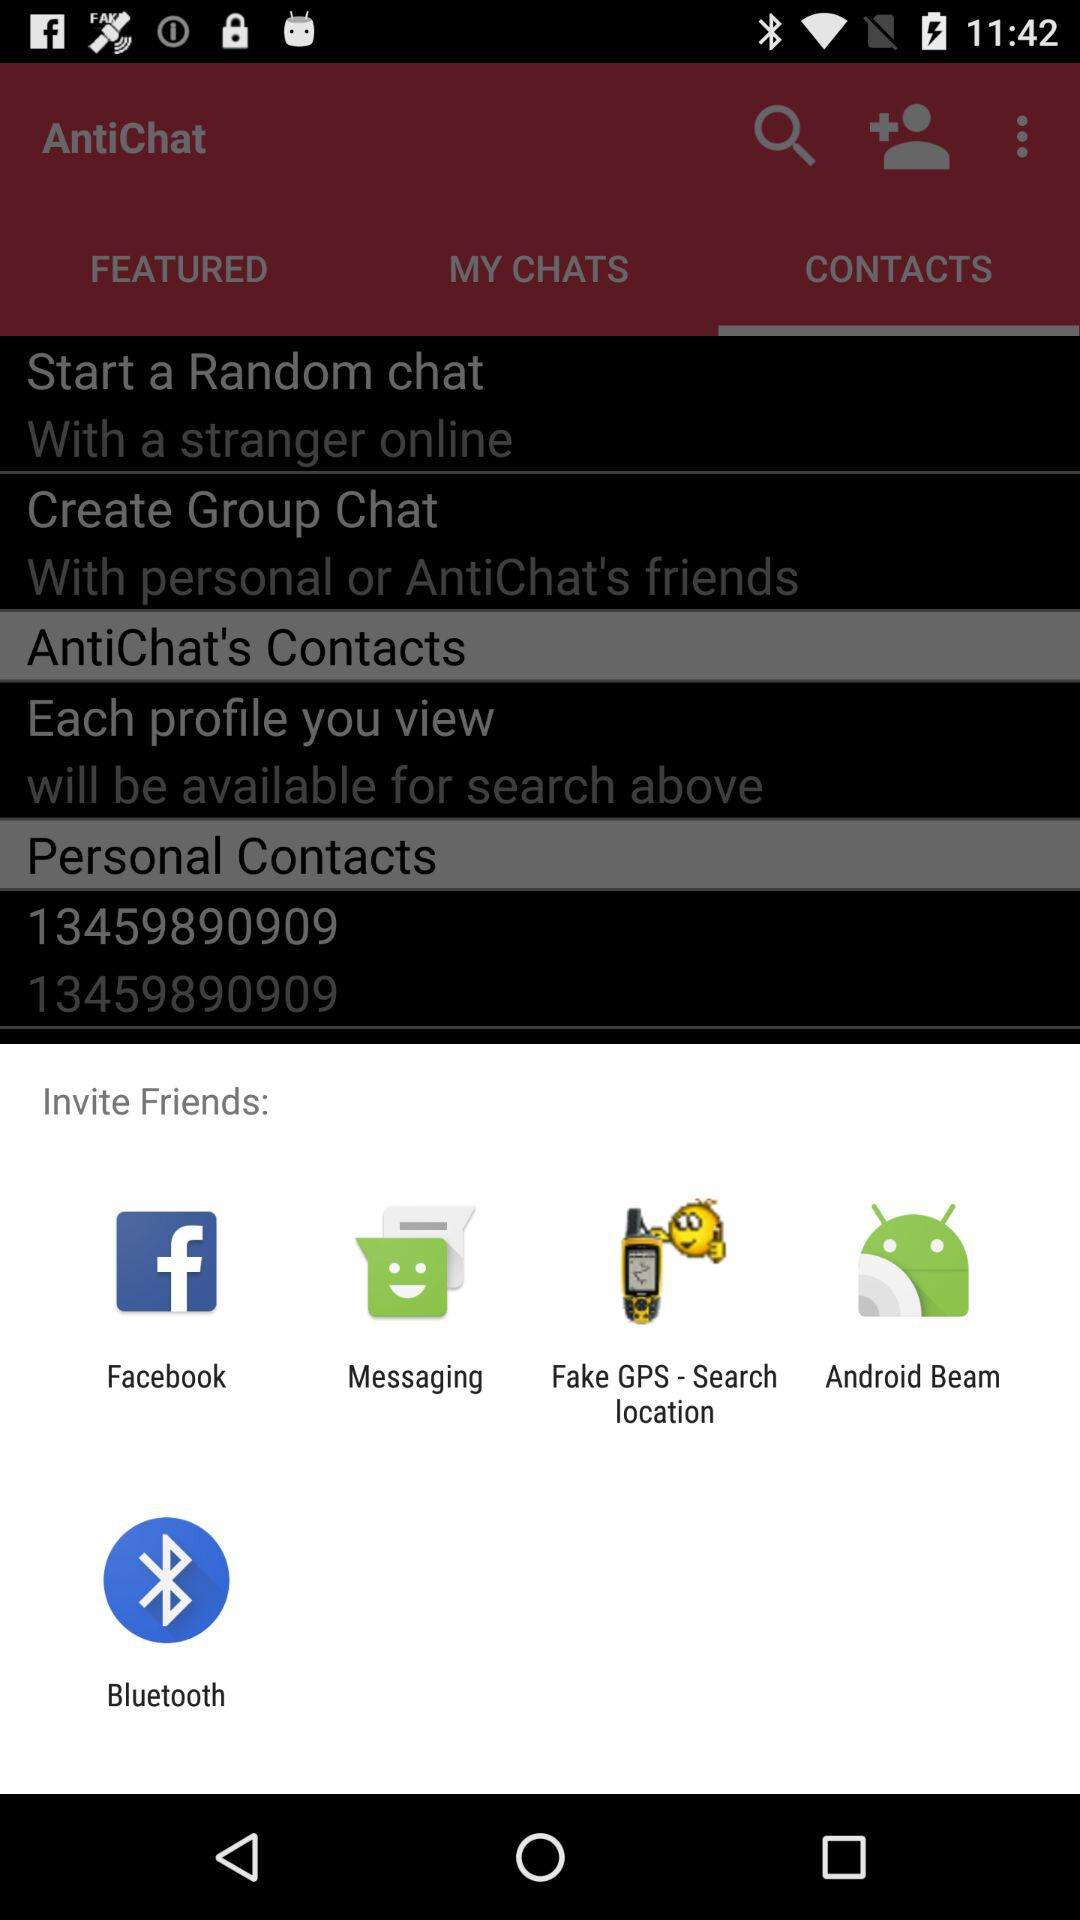What are the sharing options? The sharing options are "Facebook", "Messaging", "Fake GPS-Search location", "Android Beam", and "Bluetooth". 